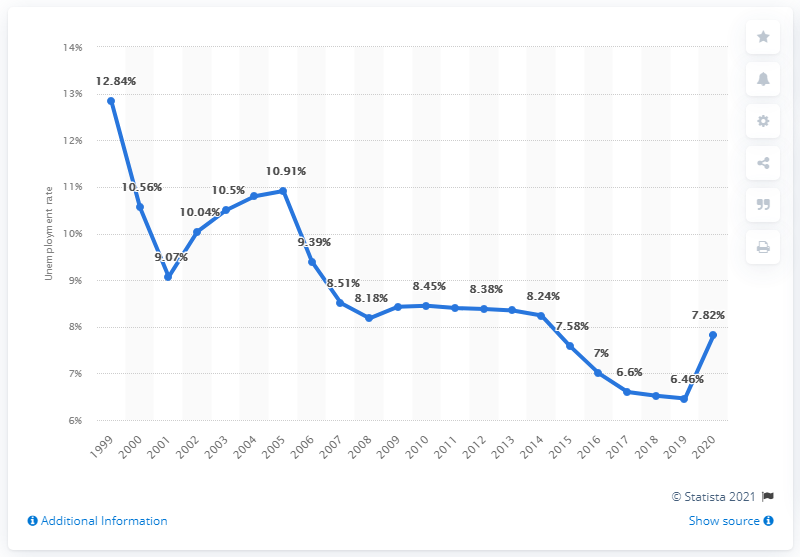Give some essential details in this illustration. According to data from 2020, the unemployment rate in Belize was 7.82%. 